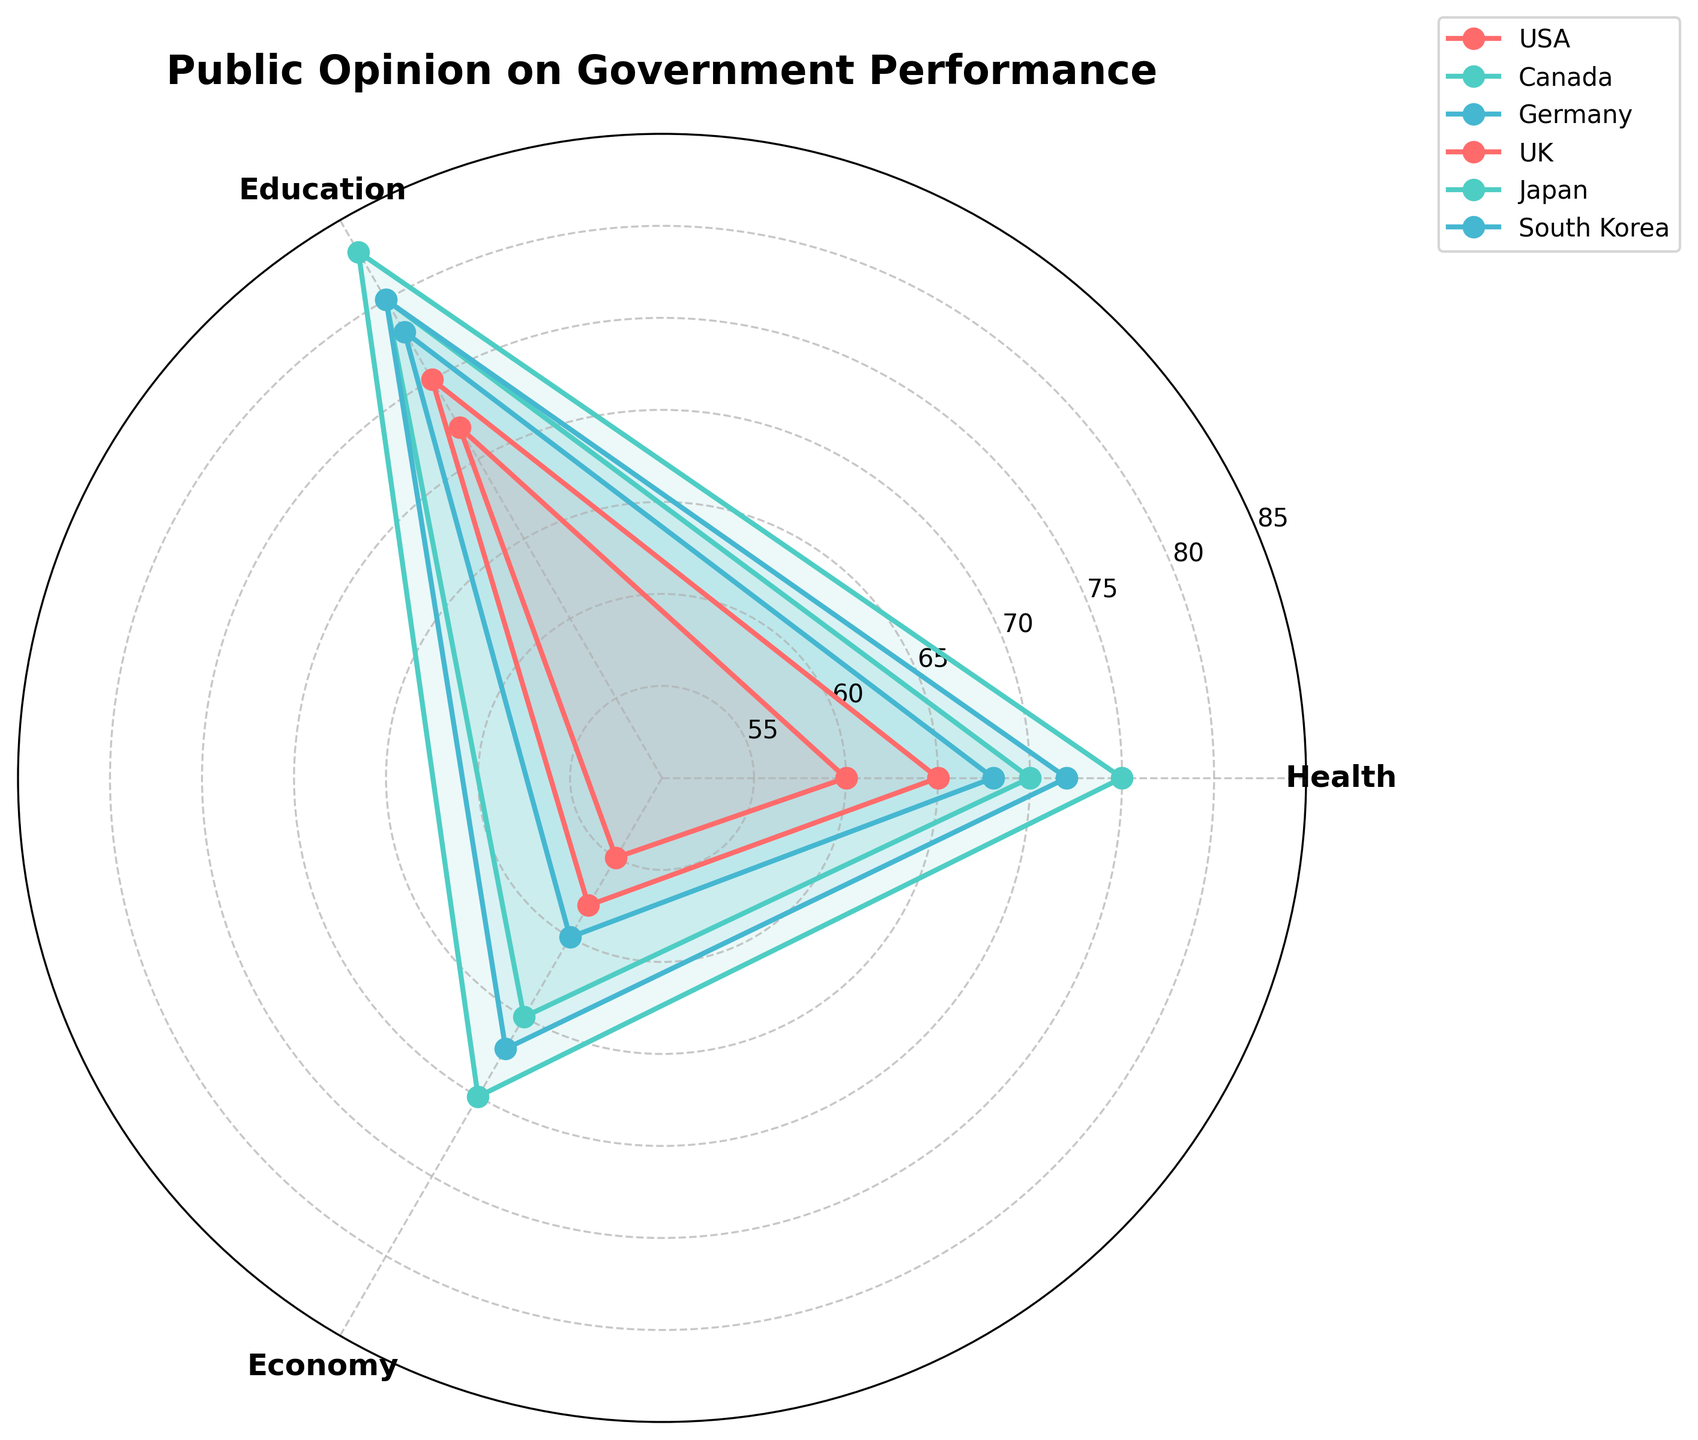What is the title of the radar chart? The title is located at the top of the radar chart and provides an overview of its content. Look for the text that is larger and bolder than the other text in the figure.
Answer: Public Opinion on Government Performance Which country has the highest public approval rating in Health? Identify the plot that has the outermost point in the Health dimension. You can refer to the labels and values on the radial axes.
Answer: Japan Between Germany and the UK, which country has a lower public approval rating in Education? Compare the positions of the points for Germany and the UK on the Education axis. Determine which point is closer to the center of the radar chart.
Answer: UK What's the average public approval rating for Canada across all three aspects? Sum the values of Health, Education, and Economy for Canada and then divide by 3 to find the average: (70 + 80 + 65) / 3
Answer: 71.67 Which aspect has the highest average approval rating across all countries? Calculate the average ratings for Health, Education, and Economy across all countries, then compare these averages to find the highest one.
Answer: Education How does Japan's approval rating in Economy compare to South Korea's? Compare the values for the Economy aspect between Japan and South Korea. Check which value is higher.
Answer: Japan Which country exhibits the lowest public approval rating in Economy? Look at the Economy axis and find the country with the innermost plot point.
Answer: UK By how many points does the USA's Education approval rating exceed its Economy approval rating? Subtract the Economy approval rating value from the Education approval rating value for the USA: 75 - 58
Answer: 17 Which country has the most consistent public approval ratings across the three aspects (least variation)? Look for the country with the plot points that are closest to a regular polygon shape, or calculate variations for each country and compare them.
Answer: Canada What is the combined total approval rating in Health and Economy for Germany? Sum the Health and Economy values for Germany: 68 + 60
Answer: 128 